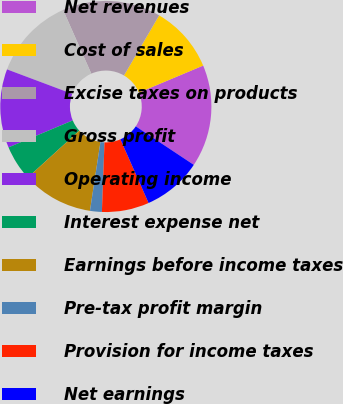Convert chart. <chart><loc_0><loc_0><loc_500><loc_500><pie_chart><fcel>Net revenues<fcel>Cost of sales<fcel>Excise taxes on products<fcel>Gross profit<fcel>Operating income<fcel>Interest expense net<fcel>Earnings before income taxes<fcel>Pre-tax profit margin<fcel>Provision for income taxes<fcel>Net earnings<nl><fcel>15.66%<fcel>10.24%<fcel>15.06%<fcel>12.65%<fcel>12.05%<fcel>5.42%<fcel>10.84%<fcel>1.81%<fcel>7.23%<fcel>9.04%<nl></chart> 